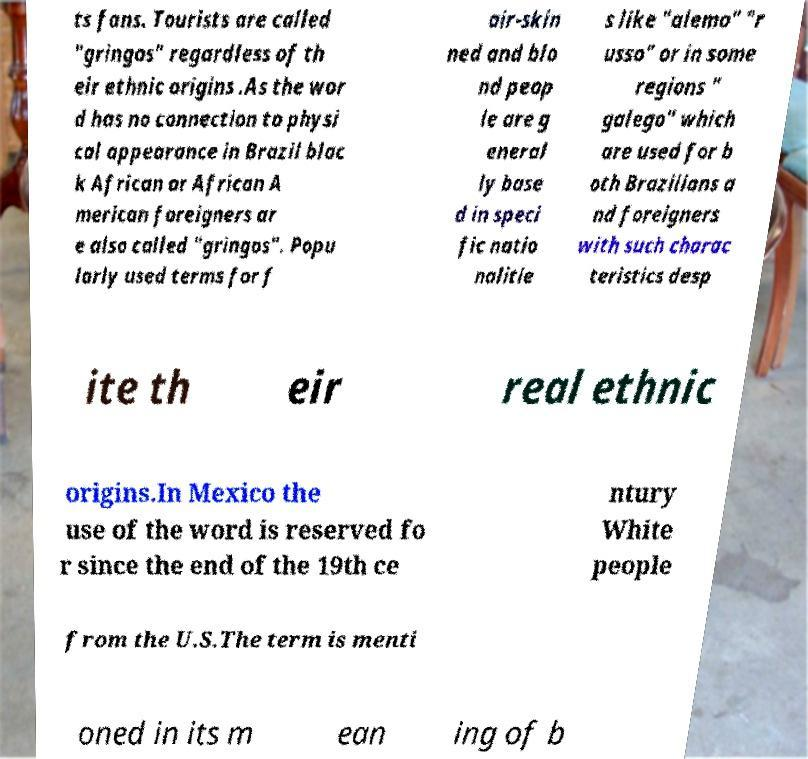Could you assist in decoding the text presented in this image and type it out clearly? ts fans. Tourists are called "gringos" regardless of th eir ethnic origins .As the wor d has no connection to physi cal appearance in Brazil blac k African or African A merican foreigners ar e also called "gringos". Popu larly used terms for f air-skin ned and blo nd peop le are g eneral ly base d in speci fic natio nalitie s like "alemo" "r usso" or in some regions " galego" which are used for b oth Brazilians a nd foreigners with such charac teristics desp ite th eir real ethnic origins.In Mexico the use of the word is reserved fo r since the end of the 19th ce ntury White people from the U.S.The term is menti oned in its m ean ing of b 